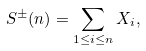Convert formula to latex. <formula><loc_0><loc_0><loc_500><loc_500>S ^ { \pm } ( n ) = \sum _ { 1 \leq i \leq n } X _ { i } ,</formula> 